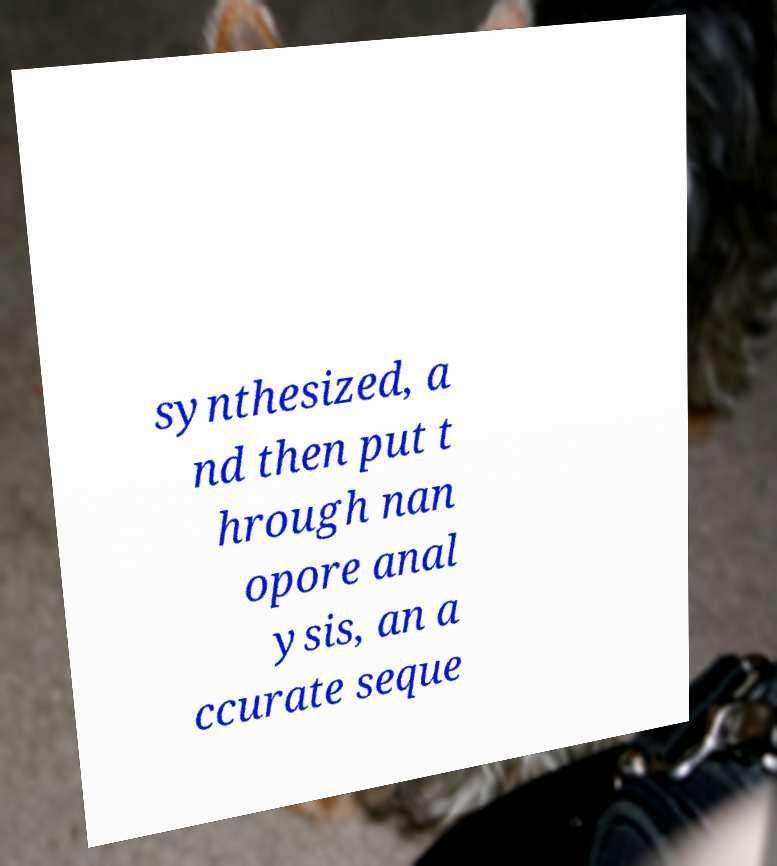For documentation purposes, I need the text within this image transcribed. Could you provide that? synthesized, a nd then put t hrough nan opore anal ysis, an a ccurate seque 